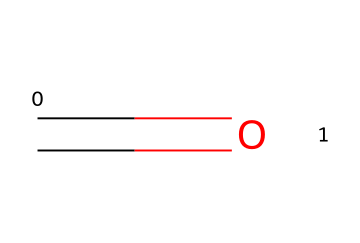How many carbon atoms are in formaldehyde? The SMILES representation "C=O" indicates that there is one carbon atom (C) in the structure.
Answer: one What type of functional group is present in formaldehyde? The presence of a carbonyl group (C=O) indicates that formaldehyde contains an aldehyde functional group.
Answer: aldehyde How many bonds are in the formaldehyde structure? The structure consists of one double bond between the carbon and oxygen (C=O) and one single bond between the carbon and hydrogen (C-H), totaling two bonds.
Answer: two What is the general formula for aldehydes? Aldehydes have a general formula of CnH2nO, where 'n' is the number of carbon atoms; in this case, with one carbon, n=1, which gives C1H2O.
Answer: CnH2nO Why is formaldehyde used in preservation techniques? Formaldehyde is effective in preserving biological specimens because it acts as a fixative, stabilizing proteins and preventing decay, due to its ability to cross-link proteins.
Answer: fixative What state is formaldehyde most commonly found in at room temperature? Formaldehyde is a gaseous compound at room temperature but is often encountered as a solution in water, known as formalin.
Answer: gaseous Does formaldehyde have an odor? Yes, formaldehyde has a strong and pungent odor, which is characteristic of many aldehydes due to their low molecular weight and volatility.
Answer: strong odor 